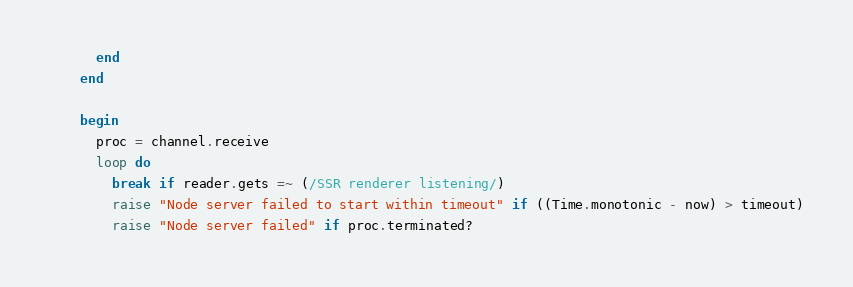Convert code to text. <code><loc_0><loc_0><loc_500><loc_500><_Crystal_>      end
    end

    begin
      proc = channel.receive
      loop do
        break if reader.gets =~ (/SSR renderer listening/)
        raise "Node server failed to start within timeout" if ((Time.monotonic - now) > timeout)
        raise "Node server failed" if proc.terminated?</code> 